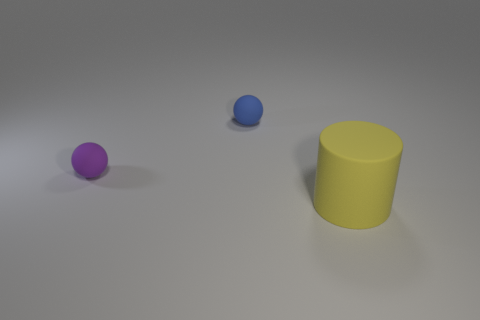There is a purple object that is made of the same material as the yellow cylinder; what is its size?
Your response must be concise. Small. The yellow rubber object is what size?
Provide a succinct answer. Large. The big thing is what shape?
Provide a short and direct response. Cylinder. There is a small rubber object to the right of the purple object; is it the same color as the large object?
Make the answer very short. No. What is the size of the blue object that is the same shape as the small purple thing?
Your answer should be very brief. Small. Is there anything else that is made of the same material as the purple thing?
Your answer should be very brief. Yes. There is a blue sphere behind the sphere that is left of the small blue sphere; are there any small blue matte spheres to the right of it?
Keep it short and to the point. No. There is a small ball to the right of the purple matte sphere; what is its material?
Provide a succinct answer. Rubber. What number of big objects are either purple matte objects or brown spheres?
Provide a succinct answer. 0. Do the thing behind the purple object and the big cylinder have the same size?
Provide a short and direct response. No. 